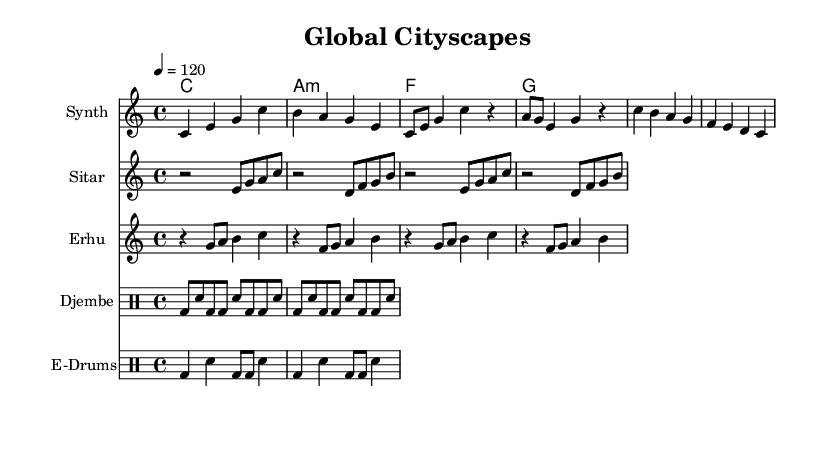What is the key signature of this music? The key signature is C major, indicated by the absence of sharps or flats.
Answer: C major What is the time signature of the piece? The time signature is 4/4, which appears at the beginning of the sheet music.
Answer: 4/4 What is the tempo marking for this piece? The tempo marking is indicated as 120 beats per minute, shown as "4 = 120" at the beginning.
Answer: 120 How many instruments are featured in this score? There are five instruments listed: Synth, Sitar, Erhu, Djembe, and E-Drums, as shown in the score's instrument section.
Answer: Five Which instrument provides the synthesized part in the composition? The synthesized part is indicated on the staff labeled "Synth" in the music sheet.
Answer: Synth What type of rhythm is played by the Djembe? The Djembe plays a simplified djembe rhythm as denoted in the drum staff section.
Answer: Simplified djembe rhythm What is the structure of the synthesis part in terms of sections? The synthesis part consists of an intro, a shortened verse, and a shortened chorus as noted in the sections of the score.
Answer: Intro, verse, chorus 